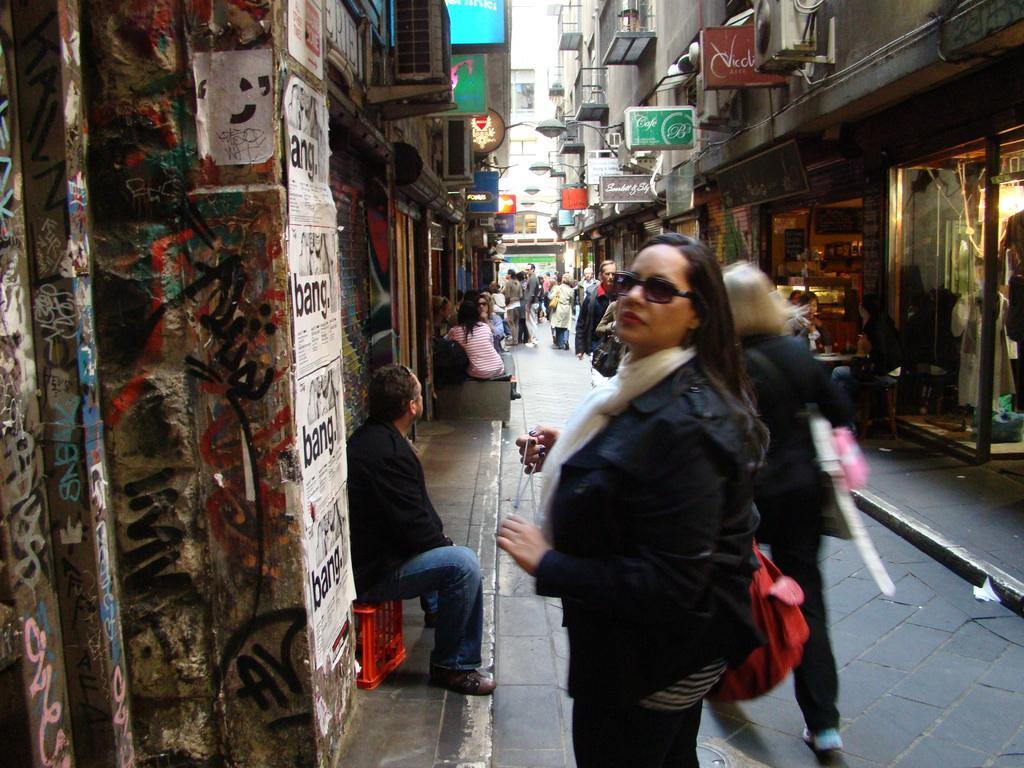Could you give a brief overview of what you see in this image? In this image we can see some buildings, some chairs, some tables, some objects on the table, some objects attached to the walls, some boards with text and images attached to the walls. There are some people are sitting, some shops, some people are holding some objects, one object on the road, one glass door, some people are standing, some shutters, some objects in the shops, some people are walking on the road, some posters with text and images attached to the walls. 